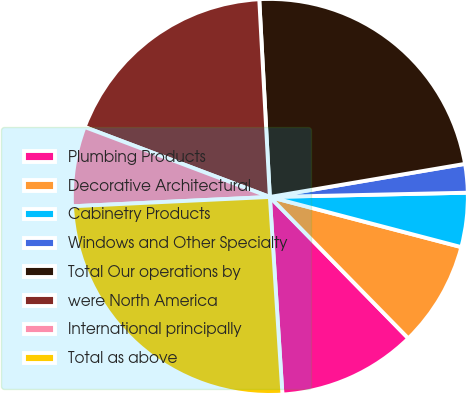Convert chart. <chart><loc_0><loc_0><loc_500><loc_500><pie_chart><fcel>Plumbing Products<fcel>Decorative Architectural<fcel>Cabinetry Products<fcel>Windows and Other Specialty<fcel>Total Our operations by<fcel>were North America<fcel>International principally<fcel>Total as above<nl><fcel>11.32%<fcel>8.59%<fcel>4.42%<fcel>2.33%<fcel>23.18%<fcel>18.4%<fcel>6.5%<fcel>25.26%<nl></chart> 